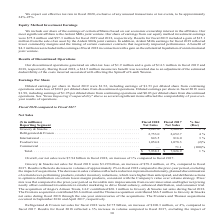From Conagra Brands's financial document, What was the net sales  of Foodservice in the fiscal year 2018 and 2017, respectively? The document shows two values: 1,054.8 and 1,078.3 (in millions). From the document: "Foodservice . 1,054.8 1,078.3 (2)% Foodservice . 1,054.8 1,078.3 (2)%..." Also, What drove the volume decrease in the International segment for the fiscal year 2018?  Based on the financial document, the answer is strategic decisions to eliminate lower margin products and to reduce promotional intensity. Also, When did the Frontera acquisition occur? According to the financial document, September 2016. The relevant text states: "The Frontera and Thanasi acquisitions occurred in September 2016 and April 2017, respectively...." Also, can you calculate: What is the proportion (in percentage) of sales from innovation in the Frontera brand over Refrigerated & Frozen’s net sales in the fiscal year 2018? Based on the calculation: 4.4/2,753.0 , the result is 0.16 (percentage). This is based on the information: "Refrigerated & Frozen . 2,753.0 2,652.7 4 %..." The key data points involved are: 2,753.0, 4.4. Also, can you calculate: What is the proportion (in percentage) of sales from the Frontera acquisition and Thanasi acquisition over Grocery & Snacks’ net sales in the fiscal year 2018? To answer this question, I need to perform calculations using the financial data. The calculation is: (8.6+66.5)/$3,287.0 , which equals 2.28 (percentage). This is based on the information: "Grocery & Snacks . $ 3,287.0 $ 3,208.8 2 % iscal 2018. The Frontera acquisition contributed $8.6 million and the Thanasi acquisition contributed $66.5 million to Grocery & Snacks net sales during mill..." The key data points involved are: 3,287.0, 66.5, 8.6. Also, can you calculate: What is the percentage change in total net sales of International and Refrigerated & Frozen from the fiscal year 2017 to 2018? To answer this question, I need to perform calculations using the financial data. The calculation is: ((843.5+2,753.0)-(816.0+2,652.7))/(816.0+2,652.7) , which equals 3.68 (percentage). This is based on the information: "Refrigerated & Frozen . 2,753.0 2,652.7 4 % International . 843.5 816.0 3 % International . 843.5 816.0 3 % Refrigerated & Frozen . 2,753.0 2,652.7 4 %..." The key data points involved are: 2,652.7, 2,753.0, 816.0. 